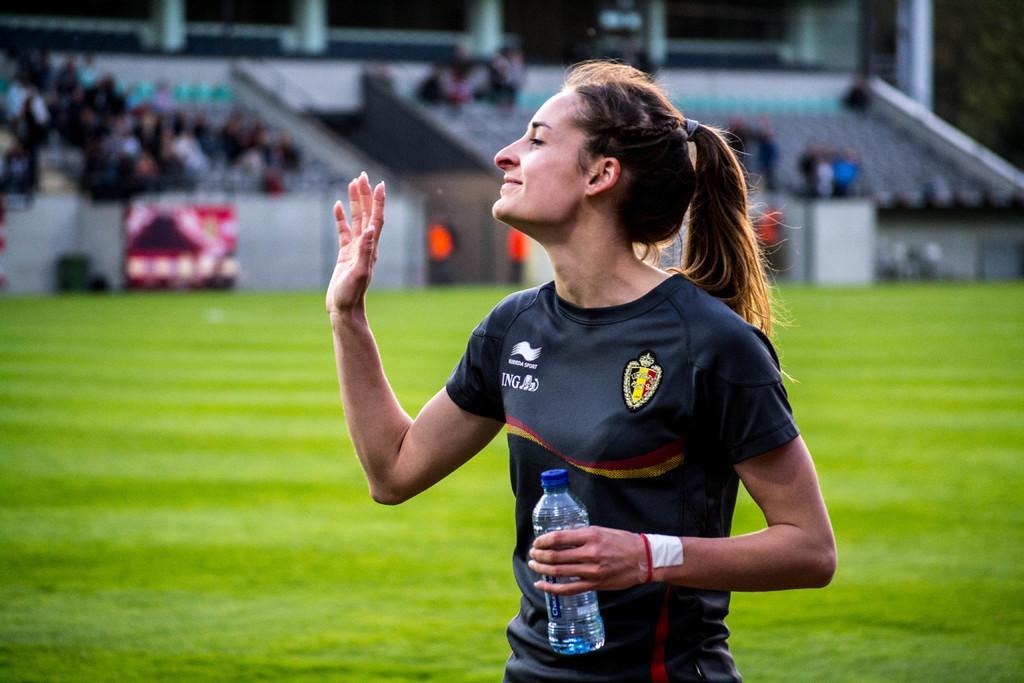Could you give a brief overview of what you see in this image? In the image we can see there is a woman who is holding a water bottle in her hand and she is waving her hand. Behind her there is a ground which is covered with grass and in the image background is very blurry. 